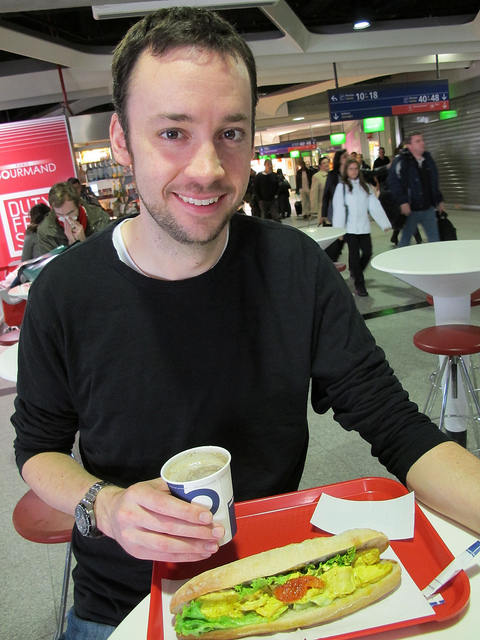<image>What pattern is on the man's shirt? There is no pattern on the man's shirt. What pattern is on the man's shirt? I am not sure what pattern is on the man's shirt. It can be solid, plain or there is no pattern. 